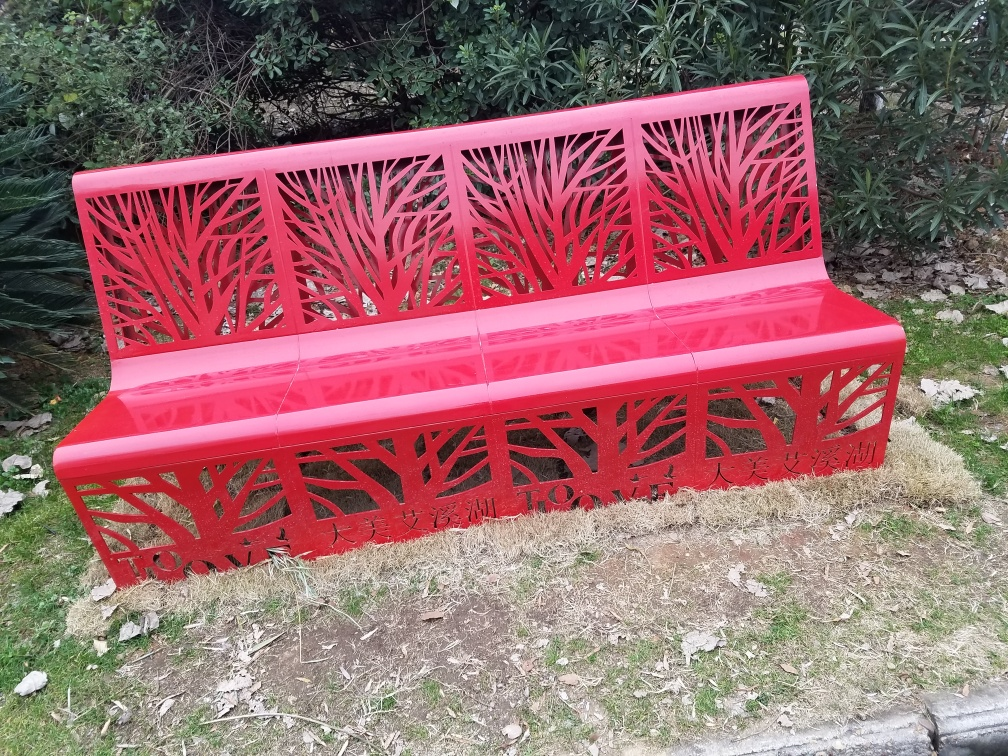Is there any noise in the image?
 No 